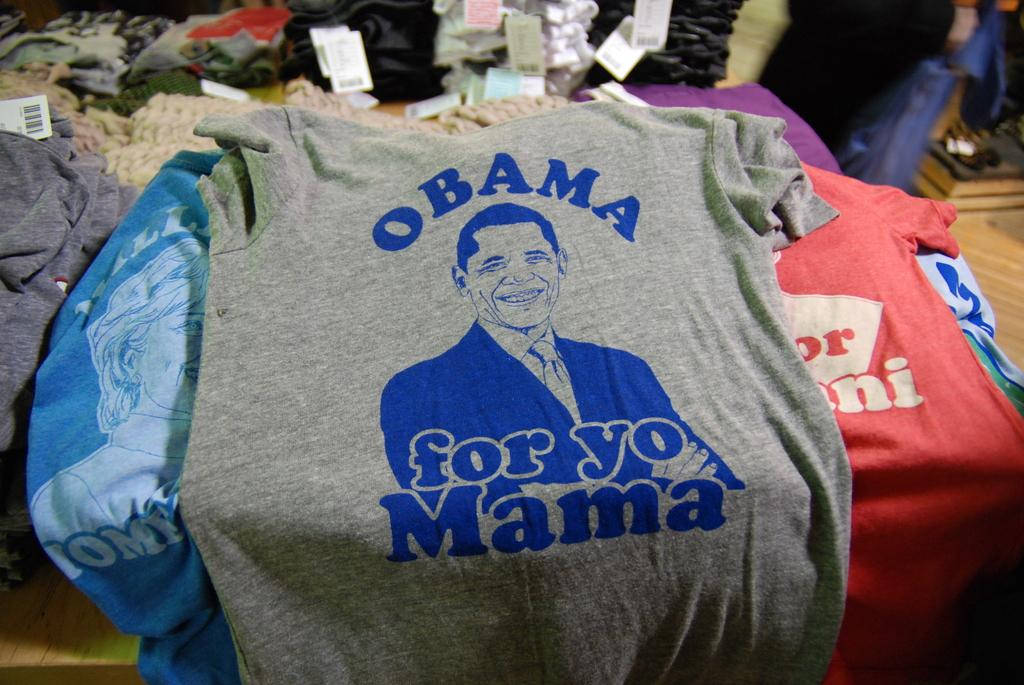<image>
Give a short and clear explanation of the subsequent image. A gray shirt with Obama for yo Mama on it. 